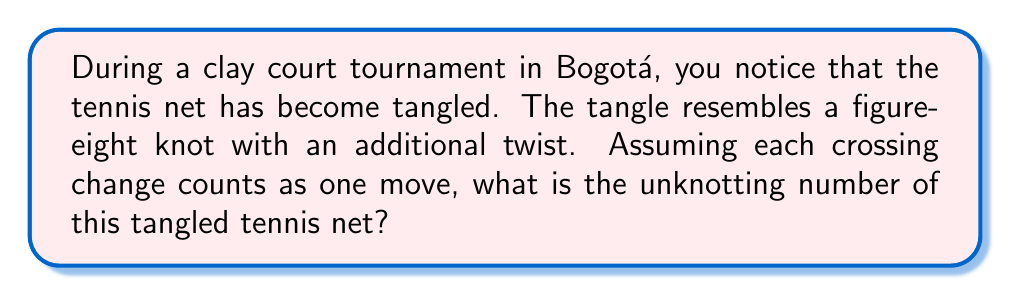Give your solution to this math problem. Let's approach this step-by-step:

1) The figure-eight knot is one of the simplest non-trivial knots. Its unknotting number is 1.

2) The additional twist adds one more crossing to the knot.

3) In knot theory, the unknotting number $u(K)$ of a knot $K$ is defined as the minimum number of crossing changes needed to transform the knot into the unknot.

4) For the figure-eight knot with an additional twist, we can represent it mathematically as:

   $$K = 4_1 \# T_1$$

   where $4_1$ represents the figure-eight knot and $T_1$ represents the additional twist.

5) The unknotting number of a composite knot satisfies the inequality:

   $$u(K_1 \# K_2) \leq u(K_1) + u(K_2)$$

6) In this case:
   
   $$u(4_1 \# T_1) \leq u(4_1) + u(T_1)$$

7) We know that $u(4_1) = 1$ and $u(T_1) = 1$, so:

   $$u(4_1 \# T_1) \leq 1 + 1 = 2$$

8) However, we need to verify if this upper bound is actually achievable.

9) By carefully analyzing the knot diagram, we can confirm that two crossing changes are indeed sufficient and necessary to unknot this tangled configuration.

Therefore, the unknotting number of this tangled tennis net is 2.
Answer: 2 